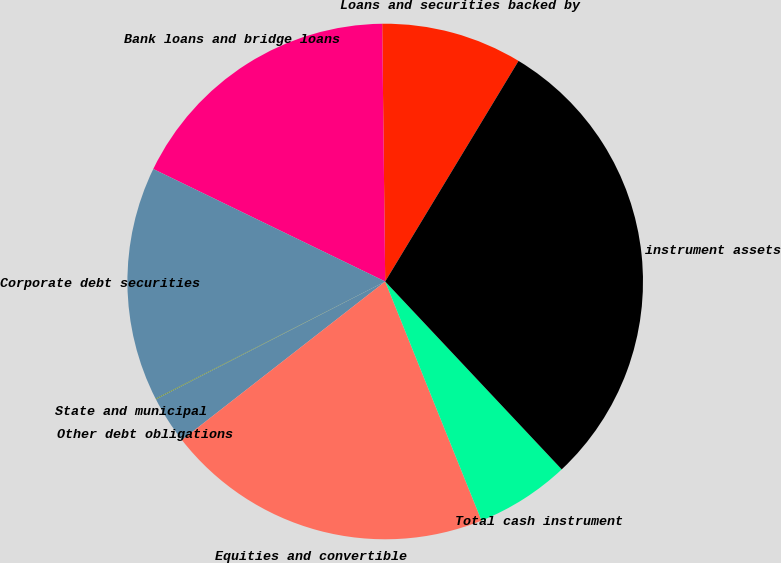Convert chart to OTSL. <chart><loc_0><loc_0><loc_500><loc_500><pie_chart><fcel>Loans and securities backed by<fcel>Bank loans and bridge loans<fcel>Corporate debt securities<fcel>State and municipal<fcel>Other debt obligations<fcel>Equities and convertible<fcel>Total cash instrument<fcel>Total cash instrument assets<nl><fcel>8.84%<fcel>17.63%<fcel>14.7%<fcel>0.05%<fcel>2.98%<fcel>20.56%<fcel>5.91%<fcel>29.35%<nl></chart> 